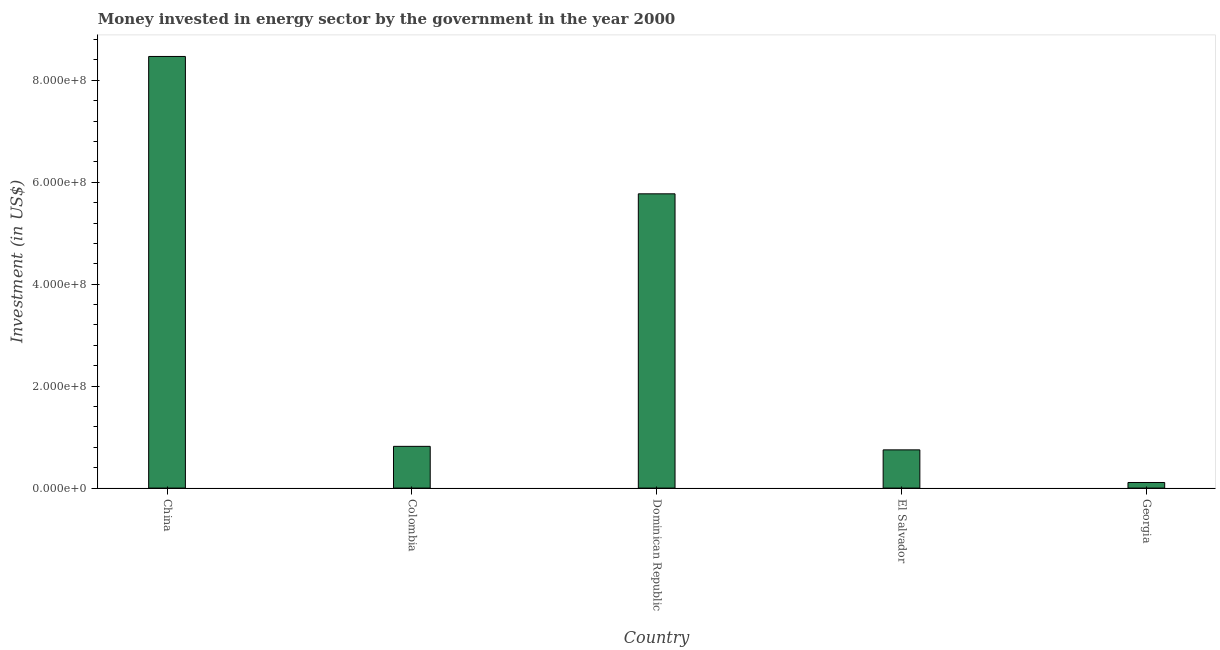Does the graph contain grids?
Your response must be concise. No. What is the title of the graph?
Offer a terse response. Money invested in energy sector by the government in the year 2000. What is the label or title of the Y-axis?
Provide a succinct answer. Investment (in US$). What is the investment in energy in China?
Keep it short and to the point. 8.47e+08. Across all countries, what is the maximum investment in energy?
Provide a short and direct response. 8.47e+08. Across all countries, what is the minimum investment in energy?
Provide a succinct answer. 1.10e+07. In which country was the investment in energy maximum?
Provide a succinct answer. China. In which country was the investment in energy minimum?
Your response must be concise. Georgia. What is the sum of the investment in energy?
Your answer should be very brief. 1.59e+09. What is the difference between the investment in energy in China and Colombia?
Make the answer very short. 7.65e+08. What is the average investment in energy per country?
Ensure brevity in your answer.  3.18e+08. What is the median investment in energy?
Give a very brief answer. 8.19e+07. What is the ratio of the investment in energy in China to that in Dominican Republic?
Your answer should be very brief. 1.47. What is the difference between the highest and the second highest investment in energy?
Make the answer very short. 2.70e+08. What is the difference between the highest and the lowest investment in energy?
Offer a very short reply. 8.36e+08. In how many countries, is the investment in energy greater than the average investment in energy taken over all countries?
Your answer should be compact. 2. How many bars are there?
Provide a succinct answer. 5. Are all the bars in the graph horizontal?
Ensure brevity in your answer.  No. What is the difference between two consecutive major ticks on the Y-axis?
Give a very brief answer. 2.00e+08. What is the Investment (in US$) in China?
Provide a succinct answer. 8.47e+08. What is the Investment (in US$) of Colombia?
Provide a succinct answer. 8.19e+07. What is the Investment (in US$) of Dominican Republic?
Provide a short and direct response. 5.77e+08. What is the Investment (in US$) of El Salvador?
Give a very brief answer. 7.50e+07. What is the Investment (in US$) of Georgia?
Your response must be concise. 1.10e+07. What is the difference between the Investment (in US$) in China and Colombia?
Provide a short and direct response. 7.65e+08. What is the difference between the Investment (in US$) in China and Dominican Republic?
Offer a terse response. 2.70e+08. What is the difference between the Investment (in US$) in China and El Salvador?
Ensure brevity in your answer.  7.72e+08. What is the difference between the Investment (in US$) in China and Georgia?
Ensure brevity in your answer.  8.36e+08. What is the difference between the Investment (in US$) in Colombia and Dominican Republic?
Your answer should be compact. -4.95e+08. What is the difference between the Investment (in US$) in Colombia and El Salvador?
Offer a terse response. 6.90e+06. What is the difference between the Investment (in US$) in Colombia and Georgia?
Keep it short and to the point. 7.09e+07. What is the difference between the Investment (in US$) in Dominican Republic and El Salvador?
Make the answer very short. 5.02e+08. What is the difference between the Investment (in US$) in Dominican Republic and Georgia?
Offer a very short reply. 5.66e+08. What is the difference between the Investment (in US$) in El Salvador and Georgia?
Keep it short and to the point. 6.40e+07. What is the ratio of the Investment (in US$) in China to that in Colombia?
Offer a terse response. 10.34. What is the ratio of the Investment (in US$) in China to that in Dominican Republic?
Provide a succinct answer. 1.47. What is the ratio of the Investment (in US$) in China to that in El Salvador?
Ensure brevity in your answer.  11.29. What is the ratio of the Investment (in US$) in China to that in Georgia?
Provide a short and direct response. 76.98. What is the ratio of the Investment (in US$) in Colombia to that in Dominican Republic?
Provide a short and direct response. 0.14. What is the ratio of the Investment (in US$) in Colombia to that in El Salvador?
Give a very brief answer. 1.09. What is the ratio of the Investment (in US$) in Colombia to that in Georgia?
Provide a succinct answer. 7.45. What is the ratio of the Investment (in US$) in Dominican Republic to that in El Salvador?
Keep it short and to the point. 7.7. What is the ratio of the Investment (in US$) in Dominican Republic to that in Georgia?
Ensure brevity in your answer.  52.48. What is the ratio of the Investment (in US$) in El Salvador to that in Georgia?
Your response must be concise. 6.82. 